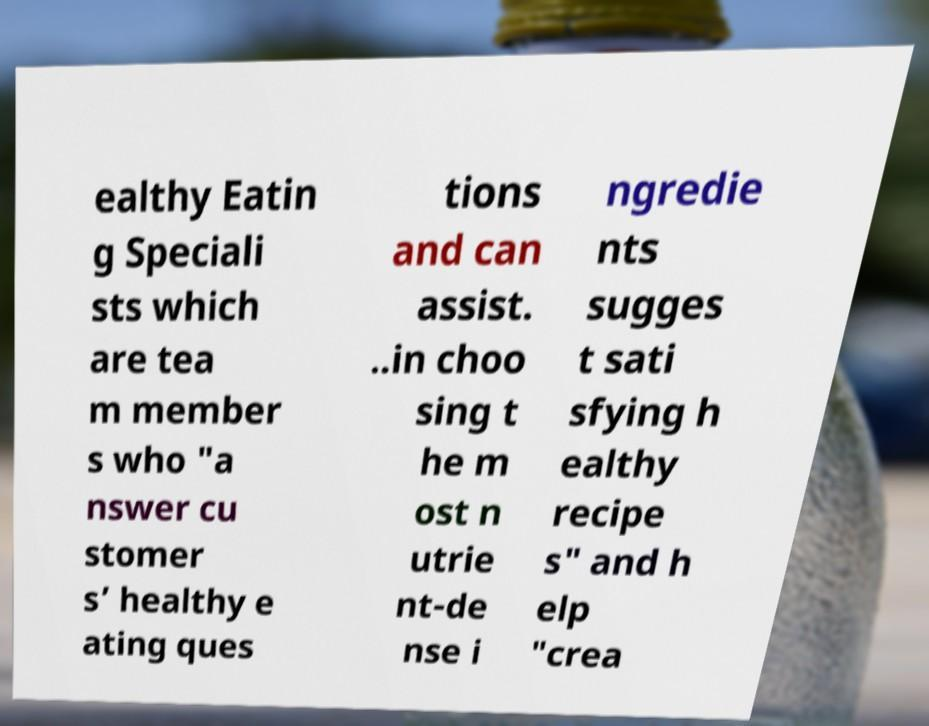Could you extract and type out the text from this image? ealthy Eatin g Speciali sts which are tea m member s who "a nswer cu stomer s’ healthy e ating ques tions and can assist. ..in choo sing t he m ost n utrie nt-de nse i ngredie nts sugges t sati sfying h ealthy recipe s" and h elp "crea 